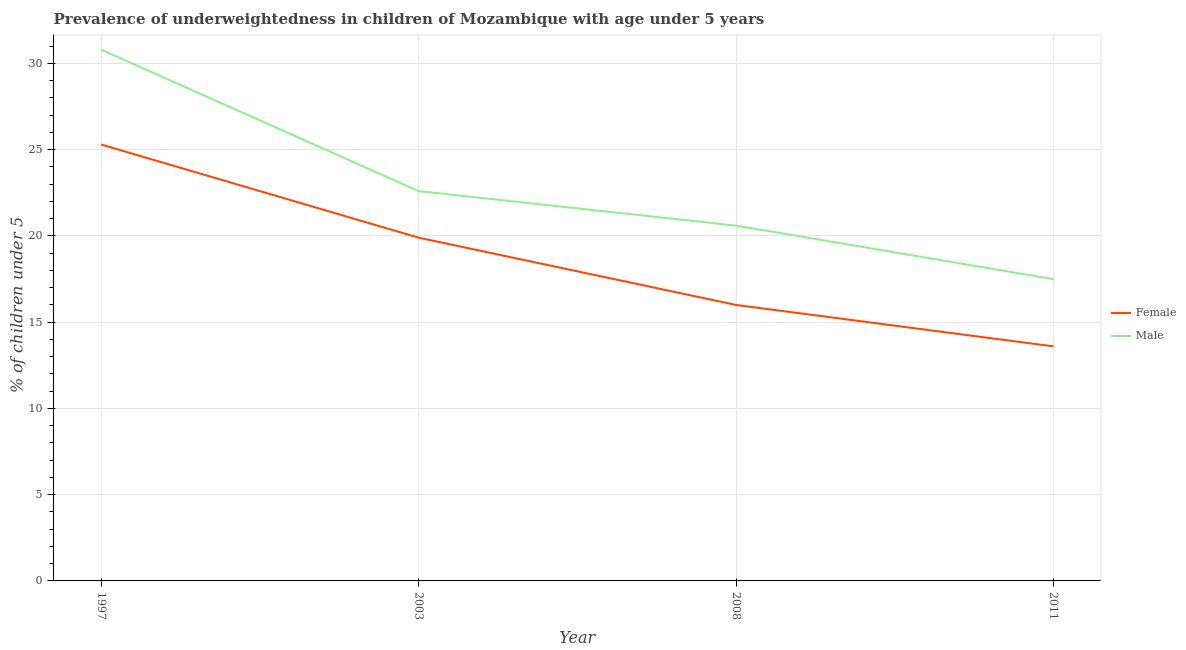Does the line corresponding to percentage of underweighted male children intersect with the line corresponding to percentage of underweighted female children?
Your answer should be compact. No. What is the percentage of underweighted female children in 2011?
Offer a terse response. 13.6. Across all years, what is the maximum percentage of underweighted male children?
Keep it short and to the point. 30.8. Across all years, what is the minimum percentage of underweighted female children?
Provide a short and direct response. 13.6. In which year was the percentage of underweighted male children minimum?
Make the answer very short. 2011. What is the total percentage of underweighted male children in the graph?
Offer a terse response. 91.5. What is the difference between the percentage of underweighted male children in 2003 and that in 2011?
Offer a very short reply. 5.1. What is the difference between the percentage of underweighted female children in 1997 and the percentage of underweighted male children in 2008?
Make the answer very short. 4.7. What is the average percentage of underweighted male children per year?
Your answer should be very brief. 22.87. In how many years, is the percentage of underweighted male children greater than 10 %?
Ensure brevity in your answer.  4. What is the ratio of the percentage of underweighted female children in 1997 to that in 2011?
Your answer should be very brief. 1.86. Is the percentage of underweighted female children in 1997 less than that in 2011?
Give a very brief answer. No. What is the difference between the highest and the second highest percentage of underweighted female children?
Give a very brief answer. 5.4. What is the difference between the highest and the lowest percentage of underweighted female children?
Keep it short and to the point. 11.7. In how many years, is the percentage of underweighted female children greater than the average percentage of underweighted female children taken over all years?
Give a very brief answer. 2. Is the percentage of underweighted female children strictly greater than the percentage of underweighted male children over the years?
Offer a terse response. No. Is the percentage of underweighted male children strictly less than the percentage of underweighted female children over the years?
Make the answer very short. No. Are the values on the major ticks of Y-axis written in scientific E-notation?
Give a very brief answer. No. Where does the legend appear in the graph?
Your answer should be very brief. Center right. How many legend labels are there?
Ensure brevity in your answer.  2. What is the title of the graph?
Make the answer very short. Prevalence of underweightedness in children of Mozambique with age under 5 years. What is the label or title of the X-axis?
Provide a short and direct response. Year. What is the label or title of the Y-axis?
Provide a succinct answer.  % of children under 5. What is the  % of children under 5 in Female in 1997?
Provide a succinct answer. 25.3. What is the  % of children under 5 in Male in 1997?
Keep it short and to the point. 30.8. What is the  % of children under 5 in Female in 2003?
Give a very brief answer. 19.9. What is the  % of children under 5 of Male in 2003?
Provide a short and direct response. 22.6. What is the  % of children under 5 in Female in 2008?
Keep it short and to the point. 16. What is the  % of children under 5 in Male in 2008?
Your answer should be compact. 20.6. What is the  % of children under 5 in Female in 2011?
Your answer should be compact. 13.6. Across all years, what is the maximum  % of children under 5 of Female?
Your answer should be very brief. 25.3. Across all years, what is the maximum  % of children under 5 in Male?
Make the answer very short. 30.8. Across all years, what is the minimum  % of children under 5 in Female?
Make the answer very short. 13.6. What is the total  % of children under 5 in Female in the graph?
Offer a very short reply. 74.8. What is the total  % of children under 5 in Male in the graph?
Your answer should be compact. 91.5. What is the difference between the  % of children under 5 in Female in 1997 and that in 2003?
Keep it short and to the point. 5.4. What is the difference between the  % of children under 5 in Male in 1997 and that in 2008?
Keep it short and to the point. 10.2. What is the difference between the  % of children under 5 of Male in 1997 and that in 2011?
Ensure brevity in your answer.  13.3. What is the difference between the  % of children under 5 of Female in 2003 and that in 2008?
Offer a very short reply. 3.9. What is the difference between the  % of children under 5 of Male in 2003 and that in 2011?
Make the answer very short. 5.1. What is the difference between the  % of children under 5 of Female in 2008 and that in 2011?
Your answer should be very brief. 2.4. What is the difference between the  % of children under 5 in Male in 2008 and that in 2011?
Offer a terse response. 3.1. What is the difference between the  % of children under 5 of Female in 1997 and the  % of children under 5 of Male in 2008?
Offer a terse response. 4.7. What is the difference between the  % of children under 5 in Female in 1997 and the  % of children under 5 in Male in 2011?
Ensure brevity in your answer.  7.8. What is the difference between the  % of children under 5 of Female in 2003 and the  % of children under 5 of Male in 2008?
Keep it short and to the point. -0.7. What is the difference between the  % of children under 5 of Female in 2003 and the  % of children under 5 of Male in 2011?
Provide a succinct answer. 2.4. What is the difference between the  % of children under 5 of Female in 2008 and the  % of children under 5 of Male in 2011?
Offer a very short reply. -1.5. What is the average  % of children under 5 in Female per year?
Provide a short and direct response. 18.7. What is the average  % of children under 5 in Male per year?
Provide a succinct answer. 22.88. In the year 2008, what is the difference between the  % of children under 5 in Female and  % of children under 5 in Male?
Your answer should be compact. -4.6. In the year 2011, what is the difference between the  % of children under 5 in Female and  % of children under 5 in Male?
Your response must be concise. -3.9. What is the ratio of the  % of children under 5 of Female in 1997 to that in 2003?
Offer a terse response. 1.27. What is the ratio of the  % of children under 5 of Male in 1997 to that in 2003?
Offer a terse response. 1.36. What is the ratio of the  % of children under 5 of Female in 1997 to that in 2008?
Your answer should be very brief. 1.58. What is the ratio of the  % of children under 5 of Male in 1997 to that in 2008?
Your answer should be compact. 1.5. What is the ratio of the  % of children under 5 in Female in 1997 to that in 2011?
Keep it short and to the point. 1.86. What is the ratio of the  % of children under 5 in Male in 1997 to that in 2011?
Provide a succinct answer. 1.76. What is the ratio of the  % of children under 5 in Female in 2003 to that in 2008?
Provide a short and direct response. 1.24. What is the ratio of the  % of children under 5 of Male in 2003 to that in 2008?
Your response must be concise. 1.1. What is the ratio of the  % of children under 5 of Female in 2003 to that in 2011?
Your answer should be compact. 1.46. What is the ratio of the  % of children under 5 in Male in 2003 to that in 2011?
Ensure brevity in your answer.  1.29. What is the ratio of the  % of children under 5 in Female in 2008 to that in 2011?
Your answer should be very brief. 1.18. What is the ratio of the  % of children under 5 in Male in 2008 to that in 2011?
Your answer should be compact. 1.18. What is the difference between the highest and the lowest  % of children under 5 of Male?
Offer a terse response. 13.3. 